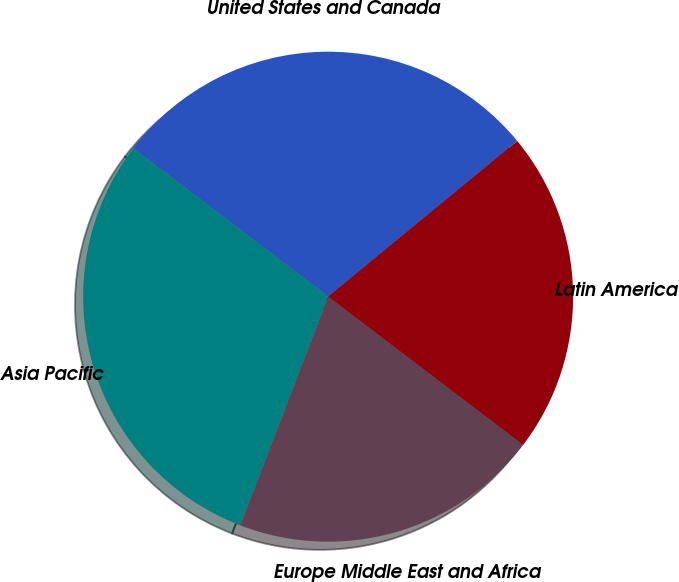<chart> <loc_0><loc_0><loc_500><loc_500><pie_chart><fcel>United States and Canada<fcel>Asia Pacific<fcel>Europe Middle East and Africa<fcel>Latin America<nl><fcel>28.69%<fcel>29.51%<fcel>20.49%<fcel>21.31%<nl></chart> 